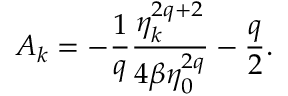<formula> <loc_0><loc_0><loc_500><loc_500>A _ { k } = - \frac { 1 } { q } \frac { \eta _ { k } ^ { 2 q + 2 } } { 4 \beta \eta _ { 0 } ^ { 2 q } } - \frac { q } { 2 } .</formula> 